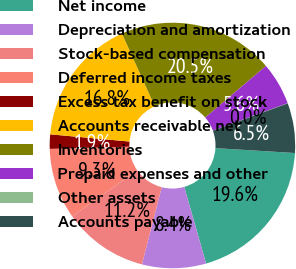<chart> <loc_0><loc_0><loc_500><loc_500><pie_chart><fcel>Net income<fcel>Depreciation and amortization<fcel>Stock-based compensation<fcel>Deferred income taxes<fcel>Excess tax benefit on stock<fcel>Accounts receivable net<fcel>Inventories<fcel>Prepaid expenses and other<fcel>Other assets<fcel>Accounts payable<nl><fcel>19.6%<fcel>8.42%<fcel>11.21%<fcel>9.35%<fcel>1.89%<fcel>16.81%<fcel>20.53%<fcel>5.62%<fcel>0.03%<fcel>6.55%<nl></chart> 